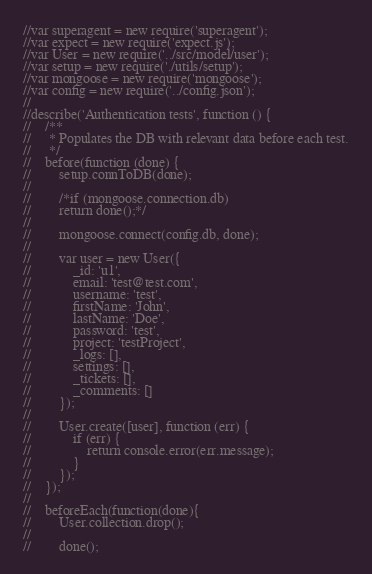<code> <loc_0><loc_0><loc_500><loc_500><_JavaScript_>//var superagent = new require('superagent');
//var expect = new require('expect.js');
//var User = new require('../src/model/user');
//var setup = new require('./utils/setup');
//var mongoose = new require('mongoose');
//var config = new require('../config.json');
//
//describe('Authentication tests', function () {
//    /**
//     * Populates the DB with relevant data before each test.
//     */
//    before(function (done) {
//        setup.connToDB(done);
//
//        /*if (mongoose.connection.db)
//        return done();*/
//
//        mongoose.connect(config.db, done);
//
//        var user = new User({
//            _id: 'u1',
//            email: 'test@test.com',
//            username: 'test',
//            firstName: 'John',
//            lastName: 'Doe',
//            password: 'test',
//            project: 'testProject',
//            _logs: [],
//            settings: [],
//            _tickets: [],
//            _comments: []
//        });
//
//        User.create([user], function (err) {
//            if (err) {
//                return console.error(err.message);
//            }
//        });
//    });
//
//    beforeEach(function(done){
//        User.collection.drop();
//
//        done();</code> 